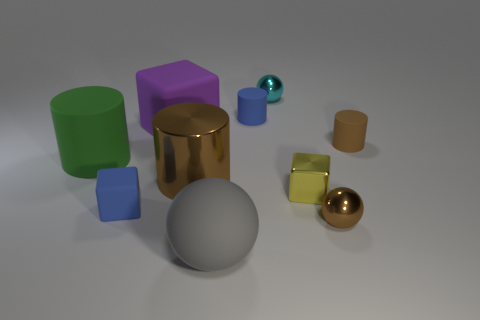There is a rubber thing that is to the left of the rubber cube that is in front of the cube on the right side of the large brown cylinder; what color is it?
Your answer should be very brief. Green. What material is the blue object that is the same shape as the purple matte thing?
Provide a short and direct response. Rubber. What number of shiny spheres are the same size as the yellow object?
Your answer should be very brief. 2. How many tiny purple shiny blocks are there?
Keep it short and to the point. 0. Do the tiny cyan ball and the blue thing that is behind the green matte cylinder have the same material?
Keep it short and to the point. No. What number of green objects are either big rubber cylinders or metallic balls?
Provide a succinct answer. 1. What size is the other cube that is made of the same material as the large block?
Your response must be concise. Small. How many brown metal objects have the same shape as the large green thing?
Provide a succinct answer. 1. Is the number of brown cylinders that are left of the small brown rubber cylinder greater than the number of gray rubber things that are in front of the cyan ball?
Give a very brief answer. No. Does the large matte cylinder have the same color as the cylinder that is in front of the green cylinder?
Keep it short and to the point. No. 